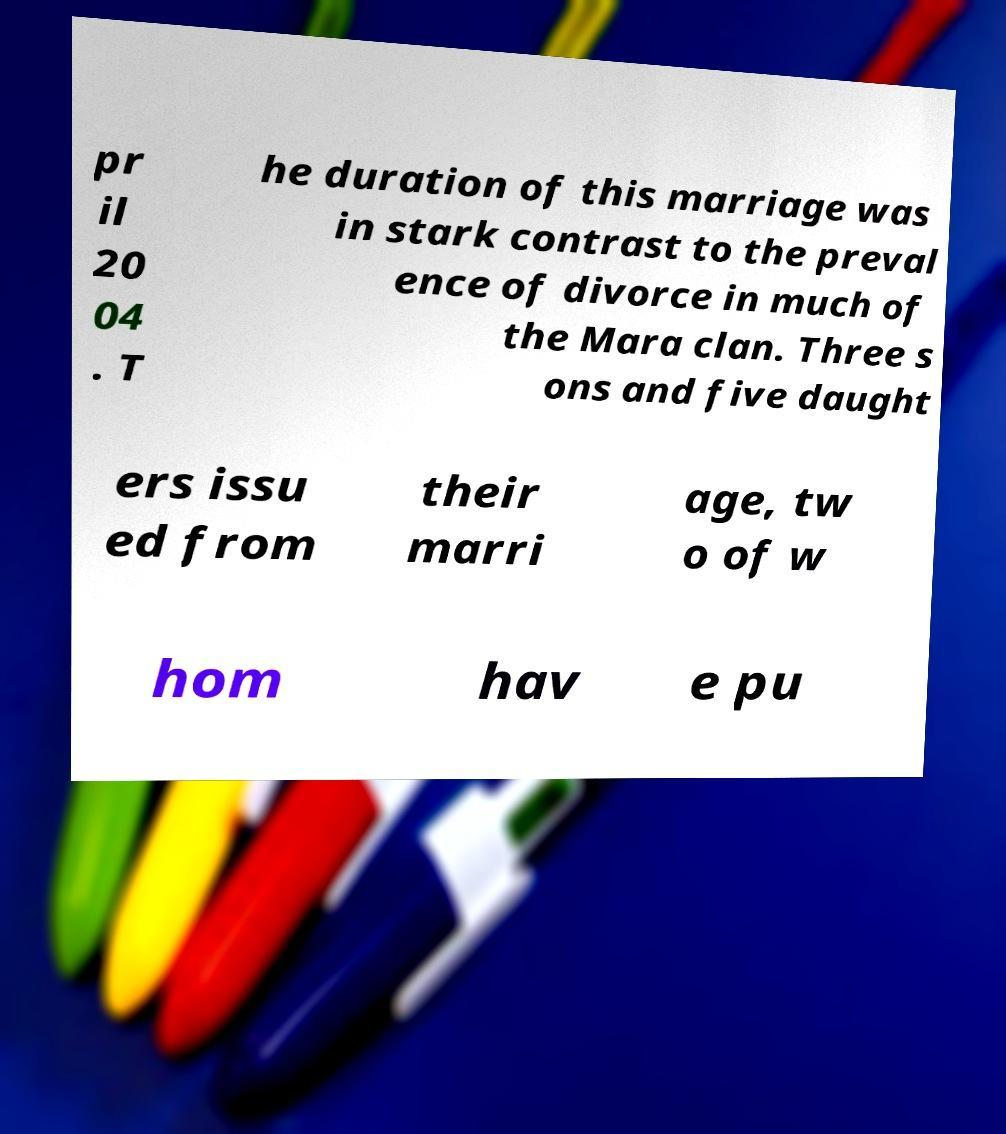Please read and relay the text visible in this image. What does it say? pr il 20 04 . T he duration of this marriage was in stark contrast to the preval ence of divorce in much of the Mara clan. Three s ons and five daught ers issu ed from their marri age, tw o of w hom hav e pu 